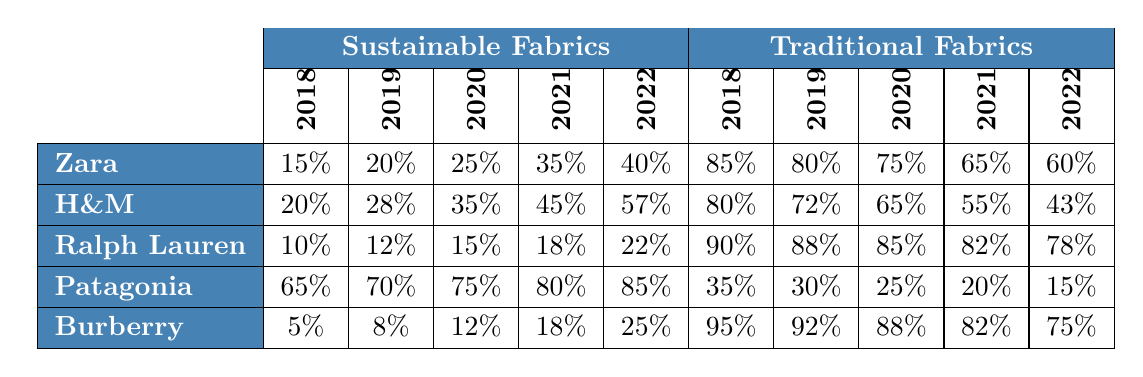What percentage of sustainable fabrics did Zara use in 2022? According to the table, Zara used 40% sustainable fabrics in 2022 as specified in that column and row.
Answer: 40% Which brand had the highest usage of sustainable fabrics in 2022? In the 2022 column for sustainable fabrics, Patagonia has the highest percentage at 85%.
Answer: Patagonia What is the average percentage of sustainable fabrics used by H&M from 2018 to 2022? To find the average, sum the percentages: (20 + 28 + 35 + 45 + 57) = 185, then divide by 5. Thus, 185/5 = 37%.
Answer: 37% Did Ralph Lauren use more than 20% sustainable fabrics in 2021? In 2021, Ralph Lauren used 18% sustainable fabrics, which is less than 20%.
Answer: No How much did the usage of traditional fabrics decrease for Zara from 2018 to 2022? The percentage of traditional fabrics for Zara in 2018 was 85%, and in 2022 it was 60%. Subtracting gives us 85% - 60% = 25%.
Answer: 25% Which brand shows a pattern of increasing sustainable fabric usage consistently year over year? Looking through all the years, both Patagonia and H&M consistently increase their sustainable fabric usage every year from 2018 to 2022.
Answer: Patagonia and H&M What was the percentage change of sustainable fabrics for Burberry from 2018 to 2022? For Burberry, sustainable fabrics went from 5% in 2018 to 25% in 2022. The change is 25% - 5% = 20%, indicating an increase of 20%.
Answer: 20% Which brand had the highest percentage of traditional fabrics in 2020? The highest percentage of traditional fabrics in 2020 is from Ralph Lauren, which used 85%.
Answer: Ralph Lauren How many brands had more than 50% sustainable fabric usage in 2022? Looking at the 2022 data, only Patagonia (85%) and H&M (57%) had more than 50%. Therefore, the count is 2.
Answer: 2 What percentage of traditional fabrics did Patagonia utilize in 2021? The table shows that Patagonia utilized 20% traditional fabrics in 2021.
Answer: 20% 